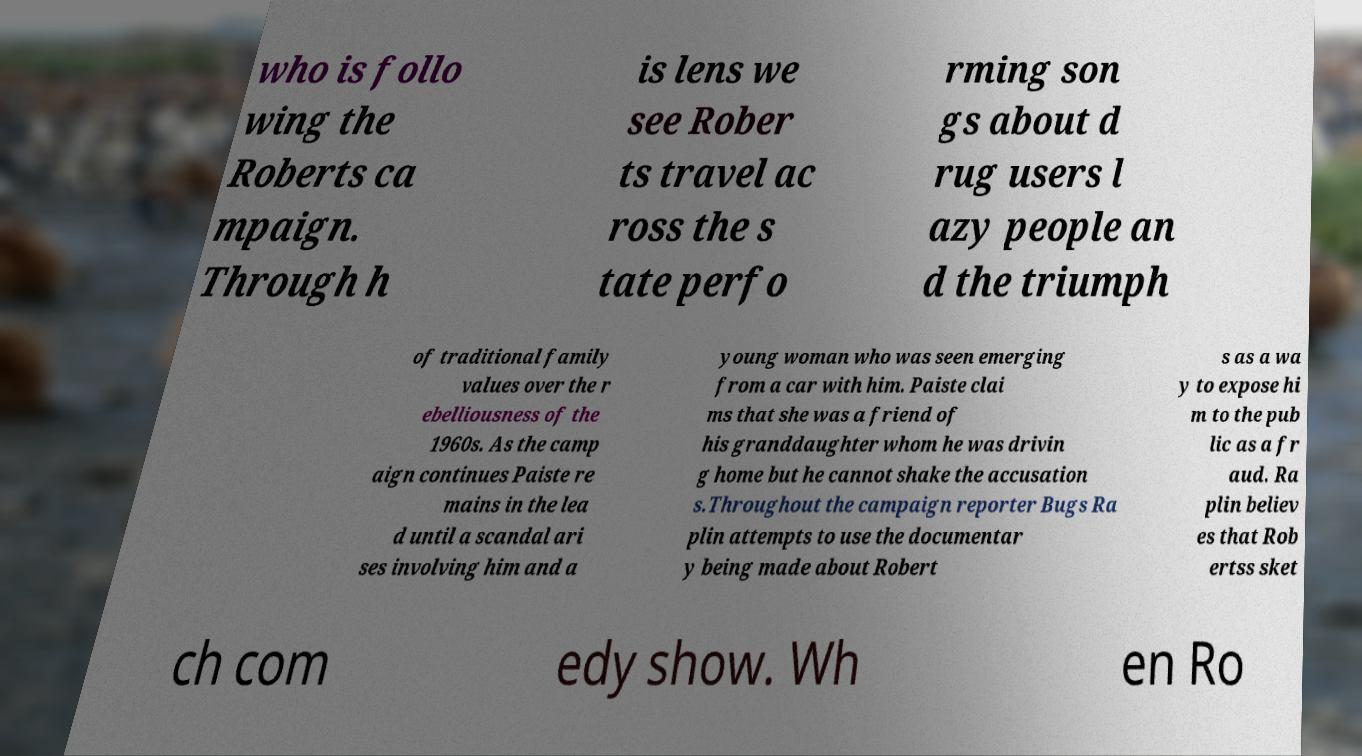For documentation purposes, I need the text within this image transcribed. Could you provide that? who is follo wing the Roberts ca mpaign. Through h is lens we see Rober ts travel ac ross the s tate perfo rming son gs about d rug users l azy people an d the triumph of traditional family values over the r ebelliousness of the 1960s. As the camp aign continues Paiste re mains in the lea d until a scandal ari ses involving him and a young woman who was seen emerging from a car with him. Paiste clai ms that she was a friend of his granddaughter whom he was drivin g home but he cannot shake the accusation s.Throughout the campaign reporter Bugs Ra plin attempts to use the documentar y being made about Robert s as a wa y to expose hi m to the pub lic as a fr aud. Ra plin believ es that Rob ertss sket ch com edy show. Wh en Ro 